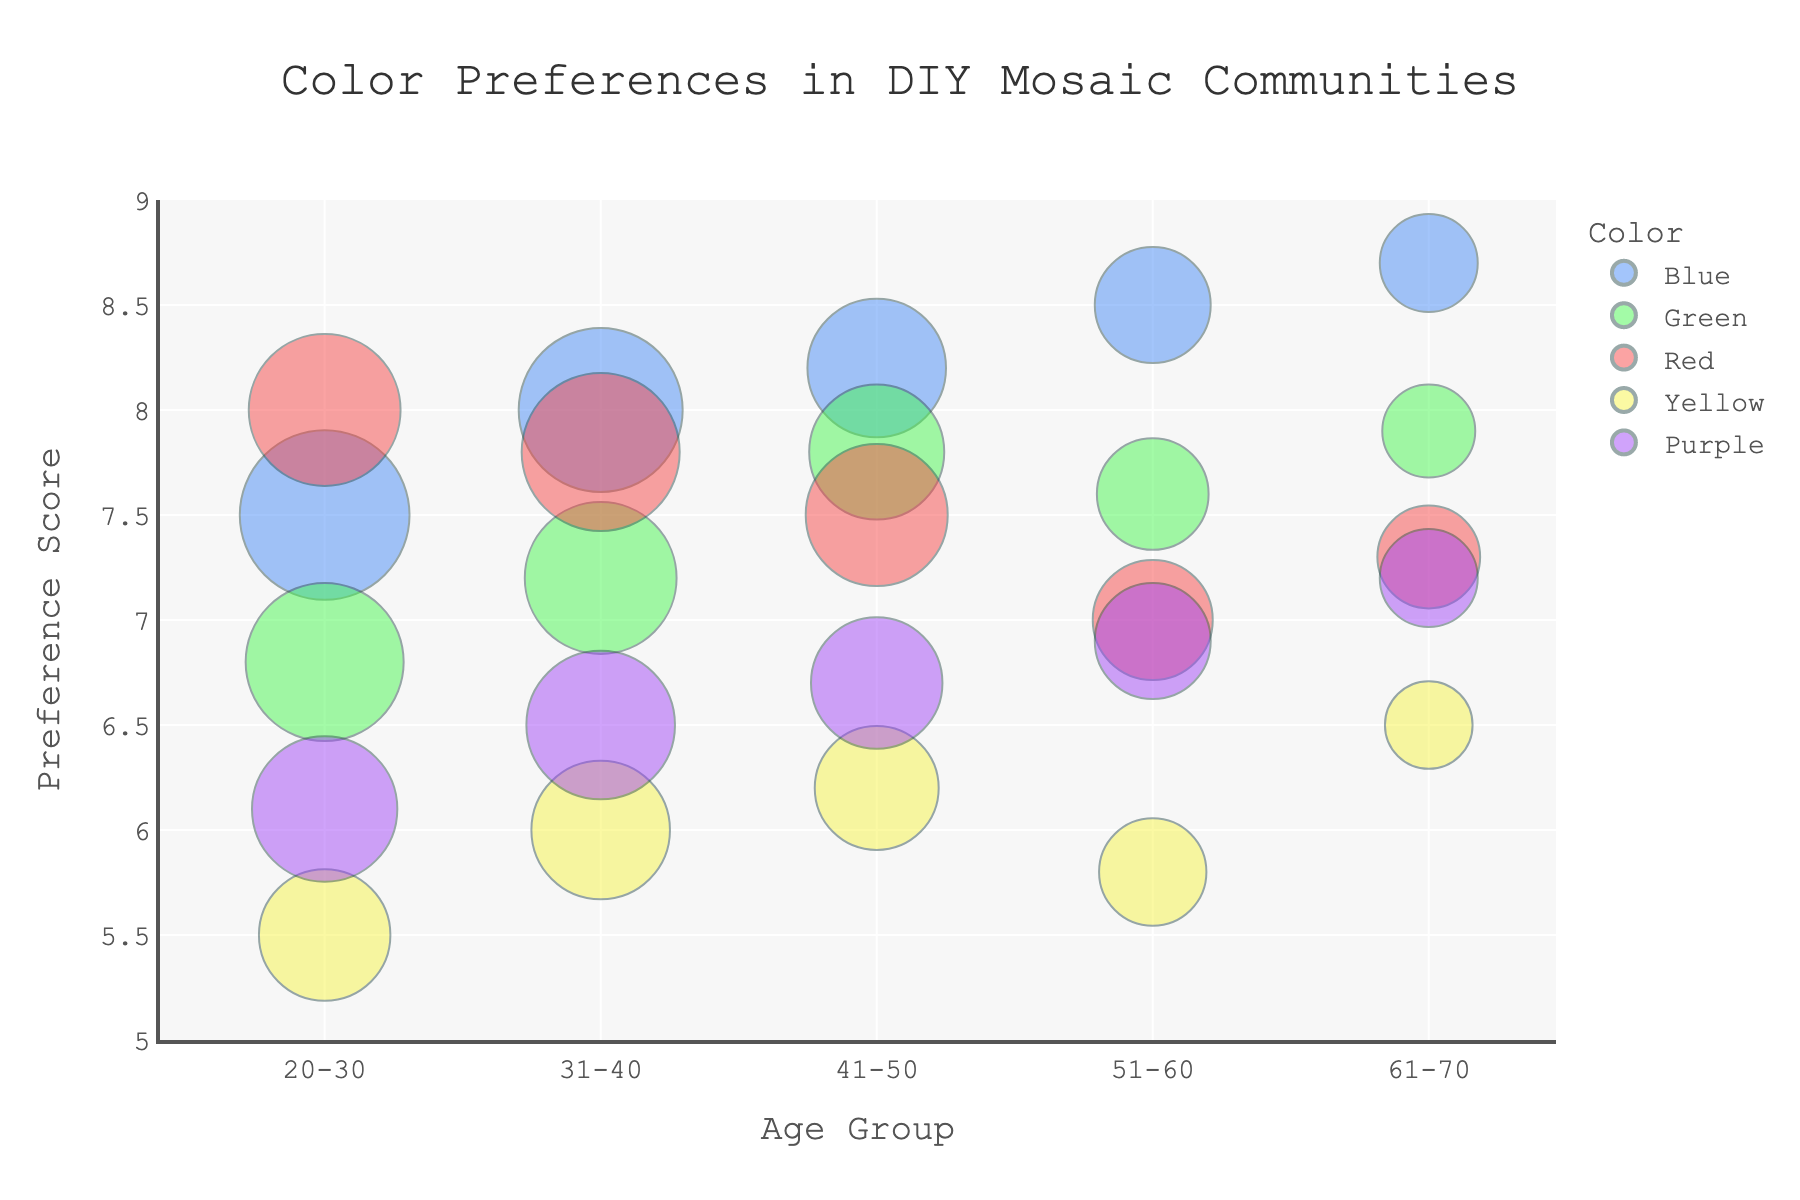What is the age group with the highest preference score for the color Blue? Look at the bubbles representing Blue in each age group and identify the highest preference score on the y-axis. The age group 61-70 has the highest preference score for Blue at 8.7.
Answer: 61-70 Which color has the highest number of users in the 20-30 age group? Observe the size of the bubbles for each color in the 20-30 age group. The largest bubble, indicating the highest number of users, corresponds to Blue, with 150 users.
Answer: Blue In the 31-40 age group, which color is least preferred? Compare the preference scores on the y-axis for each color in the 31-40 age group. Yellow has the lowest preference score at 6.0.
Answer: Yellow How does the preference score for Green change from the 41-50 age group to the 51-60 age group? Find the preference scores for Green in both age groups and calculate the difference. The score changes from 7.8 in the 41-50 age group to 7.6 in the 51-60 age group, a decrease of 0.2.
Answer: Decreases by 0.2 Which age group has the largest variation in color preference scores? Examine the range of preference scores (difference between highest and lowest scores) for each age group. The 20-30 age group has scores ranging from 5.5 to 8.0, a variation of 2.5, which is the largest range seen in any age group.
Answer: 20-30 What is the average preference score for the color Red across all age groups? Add the preference scores for Red across all age groups and divide by the number of age groups. The scores are 8.0, 7.8, 7.5, 7.0, and 7.3, totaling 37.6. Dividing by 5 gives an average of 7.52.
Answer: 7.52 Which color has the highest preference score in the 51-60 age group, and what is that score? Look at the bubbles in the 51-60 age group and determine the one with the highest preference score. Blue has the highest score at 8.5.
Answer: Blue, 8.5 Compare the number of users for the color Purple between the 31-40 and 41-50 age groups. Identify the number of users for Purple in both age groups and determine the difference. The 31-40 group has 115 users, and the 41-50 group has 90 users, resulting in 25 fewer users in the 41-50 group.
Answer: 25 fewer users What is the trend of preference scores for Blue with increasing age groups? Observe the pattern of preference scores for Blue across all age groups. The preference scores increase from 7.5, 8.0, 8.2, 8.5, to 8.7, indicating an upward trend.
Answer: Increasing trend 